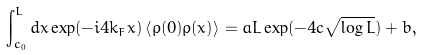<formula> <loc_0><loc_0><loc_500><loc_500>\int _ { c _ { 0 } } ^ { L } d x \exp ( - i 4 k _ { F } x ) \left \langle \rho ( 0 ) \rho ( x ) \right \rangle = a L \exp ( - 4 c \sqrt { \log L } ) + b ,</formula> 